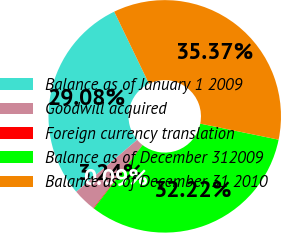Convert chart. <chart><loc_0><loc_0><loc_500><loc_500><pie_chart><fcel>Balance as of January 1 2009<fcel>Goodwill acquired<fcel>Foreign currency translation<fcel>Balance as of December 312009<fcel>Balance as of December 31 2010<nl><fcel>29.08%<fcel>3.24%<fcel>0.09%<fcel>32.22%<fcel>35.37%<nl></chart> 